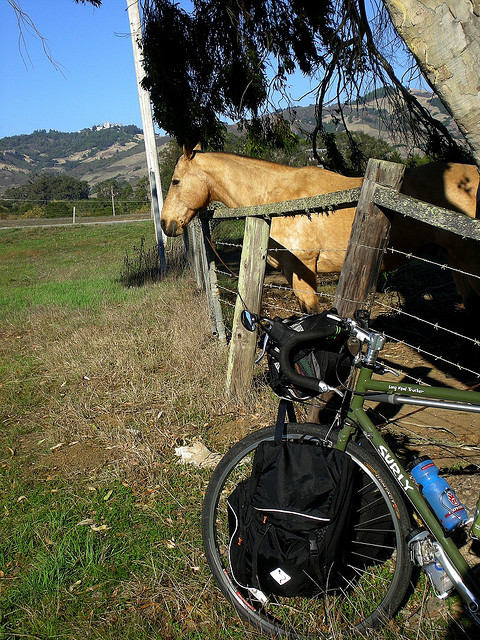Identify and read out the text in this image. SURLY 